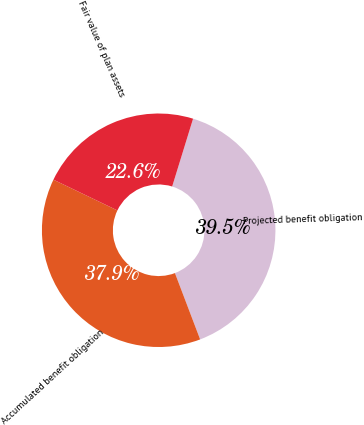<chart> <loc_0><loc_0><loc_500><loc_500><pie_chart><fcel>Projected benefit obligation<fcel>Accumulated benefit obligation<fcel>Fair value of plan assets<nl><fcel>39.46%<fcel>37.91%<fcel>22.63%<nl></chart> 